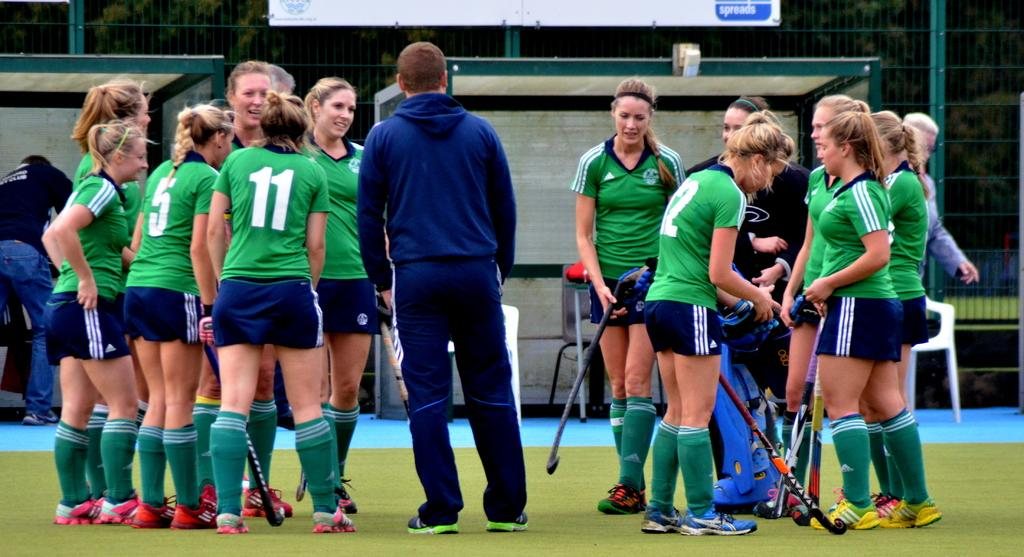Provide a one-sentence caption for the provided image. a bunch of female hockey players, one of whom is wearing a number 11 shirt. 